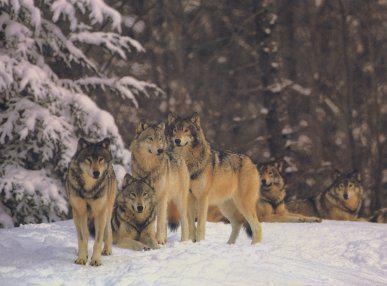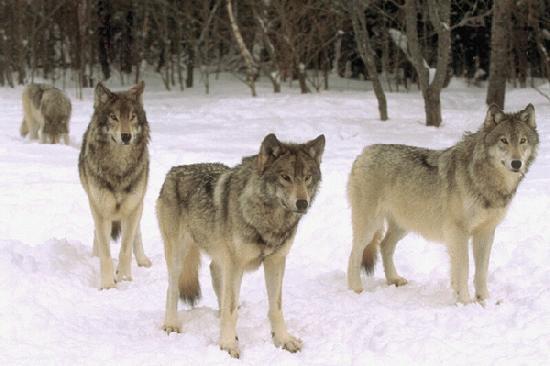The first image is the image on the left, the second image is the image on the right. Examine the images to the left and right. Is the description "There is at least one wolf that is completely black." accurate? Answer yes or no. No. The first image is the image on the left, the second image is the image on the right. Considering the images on both sides, is "An image shows exactly three wolves, including one black one, running in a rightward direction." valid? Answer yes or no. No. 